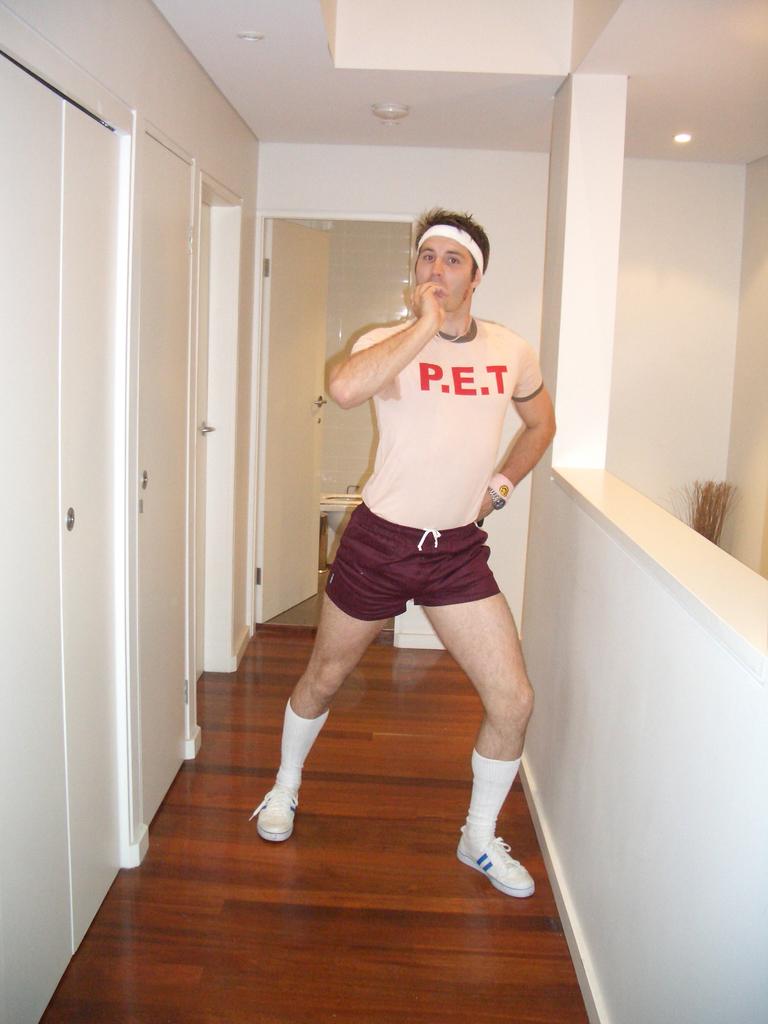What color are the letters on his t-shirt?
Keep it short and to the point. Red. 